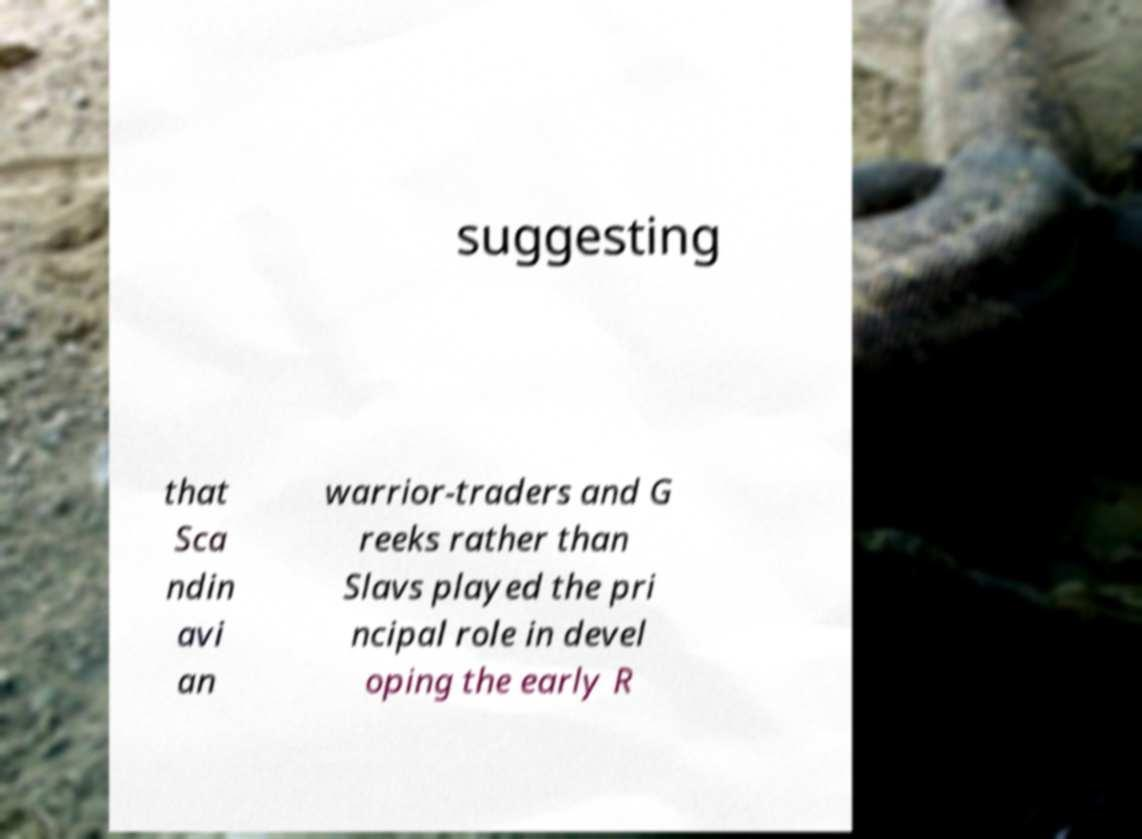For documentation purposes, I need the text within this image transcribed. Could you provide that? suggesting that Sca ndin avi an warrior-traders and G reeks rather than Slavs played the pri ncipal role in devel oping the early R 